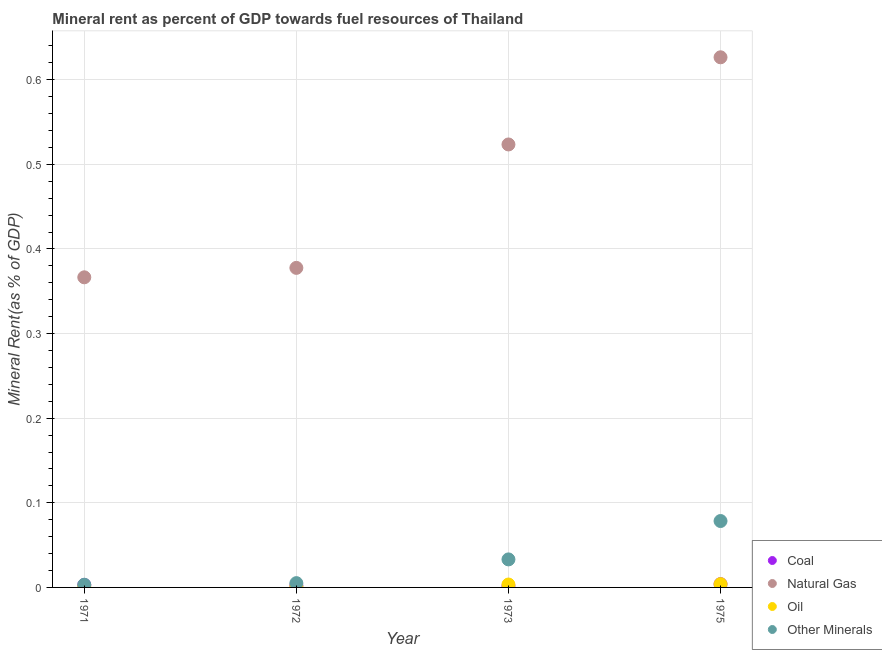What is the  rent of other minerals in 1971?
Your answer should be very brief. 0. Across all years, what is the maximum natural gas rent?
Keep it short and to the point. 0.63. Across all years, what is the minimum coal rent?
Offer a terse response. 0. In which year was the coal rent maximum?
Keep it short and to the point. 1975. What is the total natural gas rent in the graph?
Give a very brief answer. 1.89. What is the difference between the natural gas rent in 1972 and that in 1975?
Ensure brevity in your answer.  -0.25. What is the difference between the natural gas rent in 1972 and the coal rent in 1973?
Your answer should be compact. 0.38. What is the average coal rent per year?
Provide a succinct answer. 0. In the year 1975, what is the difference between the natural gas rent and oil rent?
Provide a succinct answer. 0.62. What is the ratio of the  rent of other minerals in 1971 to that in 1973?
Make the answer very short. 0.1. What is the difference between the highest and the second highest oil rent?
Provide a succinct answer. 0. What is the difference between the highest and the lowest  rent of other minerals?
Give a very brief answer. 0.08. In how many years, is the oil rent greater than the average oil rent taken over all years?
Offer a terse response. 2. Is the sum of the natural gas rent in 1973 and 1975 greater than the maximum  rent of other minerals across all years?
Offer a terse response. Yes. Is it the case that in every year, the sum of the coal rent and natural gas rent is greater than the oil rent?
Give a very brief answer. Yes. Does the  rent of other minerals monotonically increase over the years?
Offer a very short reply. Yes. Does the graph contain any zero values?
Give a very brief answer. No. Does the graph contain grids?
Offer a very short reply. Yes. What is the title of the graph?
Give a very brief answer. Mineral rent as percent of GDP towards fuel resources of Thailand. Does "Public sector management" appear as one of the legend labels in the graph?
Offer a very short reply. No. What is the label or title of the X-axis?
Offer a very short reply. Year. What is the label or title of the Y-axis?
Your answer should be compact. Mineral Rent(as % of GDP). What is the Mineral Rent(as % of GDP) in Coal in 1971?
Your response must be concise. 0. What is the Mineral Rent(as % of GDP) in Natural Gas in 1971?
Your answer should be very brief. 0.37. What is the Mineral Rent(as % of GDP) of Oil in 1971?
Your response must be concise. 0. What is the Mineral Rent(as % of GDP) in Other Minerals in 1971?
Make the answer very short. 0. What is the Mineral Rent(as % of GDP) in Coal in 1972?
Make the answer very short. 0. What is the Mineral Rent(as % of GDP) in Natural Gas in 1972?
Give a very brief answer. 0.38. What is the Mineral Rent(as % of GDP) in Oil in 1972?
Provide a succinct answer. 0. What is the Mineral Rent(as % of GDP) of Other Minerals in 1972?
Provide a succinct answer. 0.01. What is the Mineral Rent(as % of GDP) in Coal in 1973?
Your answer should be very brief. 0. What is the Mineral Rent(as % of GDP) of Natural Gas in 1973?
Provide a short and direct response. 0.52. What is the Mineral Rent(as % of GDP) in Oil in 1973?
Ensure brevity in your answer.  0. What is the Mineral Rent(as % of GDP) in Other Minerals in 1973?
Keep it short and to the point. 0.03. What is the Mineral Rent(as % of GDP) of Coal in 1975?
Offer a terse response. 0. What is the Mineral Rent(as % of GDP) in Natural Gas in 1975?
Your response must be concise. 0.63. What is the Mineral Rent(as % of GDP) in Oil in 1975?
Make the answer very short. 0. What is the Mineral Rent(as % of GDP) of Other Minerals in 1975?
Provide a succinct answer. 0.08. Across all years, what is the maximum Mineral Rent(as % of GDP) of Coal?
Offer a very short reply. 0. Across all years, what is the maximum Mineral Rent(as % of GDP) in Natural Gas?
Ensure brevity in your answer.  0.63. Across all years, what is the maximum Mineral Rent(as % of GDP) in Oil?
Your answer should be compact. 0. Across all years, what is the maximum Mineral Rent(as % of GDP) in Other Minerals?
Your answer should be very brief. 0.08. Across all years, what is the minimum Mineral Rent(as % of GDP) of Coal?
Ensure brevity in your answer.  0. Across all years, what is the minimum Mineral Rent(as % of GDP) in Natural Gas?
Your response must be concise. 0.37. Across all years, what is the minimum Mineral Rent(as % of GDP) in Oil?
Your answer should be compact. 0. Across all years, what is the minimum Mineral Rent(as % of GDP) in Other Minerals?
Ensure brevity in your answer.  0. What is the total Mineral Rent(as % of GDP) in Coal in the graph?
Make the answer very short. 0.01. What is the total Mineral Rent(as % of GDP) of Natural Gas in the graph?
Give a very brief answer. 1.89. What is the total Mineral Rent(as % of GDP) of Oil in the graph?
Ensure brevity in your answer.  0.01. What is the total Mineral Rent(as % of GDP) in Other Minerals in the graph?
Make the answer very short. 0.12. What is the difference between the Mineral Rent(as % of GDP) of Coal in 1971 and that in 1972?
Provide a succinct answer. 0. What is the difference between the Mineral Rent(as % of GDP) of Natural Gas in 1971 and that in 1972?
Give a very brief answer. -0.01. What is the difference between the Mineral Rent(as % of GDP) in Oil in 1971 and that in 1972?
Provide a succinct answer. -0. What is the difference between the Mineral Rent(as % of GDP) of Other Minerals in 1971 and that in 1972?
Your response must be concise. -0. What is the difference between the Mineral Rent(as % of GDP) in Coal in 1971 and that in 1973?
Give a very brief answer. 0. What is the difference between the Mineral Rent(as % of GDP) of Natural Gas in 1971 and that in 1973?
Ensure brevity in your answer.  -0.16. What is the difference between the Mineral Rent(as % of GDP) in Oil in 1971 and that in 1973?
Your answer should be compact. -0. What is the difference between the Mineral Rent(as % of GDP) of Other Minerals in 1971 and that in 1973?
Offer a very short reply. -0.03. What is the difference between the Mineral Rent(as % of GDP) of Coal in 1971 and that in 1975?
Provide a short and direct response. -0. What is the difference between the Mineral Rent(as % of GDP) of Natural Gas in 1971 and that in 1975?
Make the answer very short. -0.26. What is the difference between the Mineral Rent(as % of GDP) of Oil in 1971 and that in 1975?
Offer a terse response. -0. What is the difference between the Mineral Rent(as % of GDP) in Other Minerals in 1971 and that in 1975?
Offer a very short reply. -0.08. What is the difference between the Mineral Rent(as % of GDP) in Coal in 1972 and that in 1973?
Offer a terse response. 0. What is the difference between the Mineral Rent(as % of GDP) of Natural Gas in 1972 and that in 1973?
Offer a very short reply. -0.15. What is the difference between the Mineral Rent(as % of GDP) of Oil in 1972 and that in 1973?
Your answer should be very brief. -0. What is the difference between the Mineral Rent(as % of GDP) of Other Minerals in 1972 and that in 1973?
Give a very brief answer. -0.03. What is the difference between the Mineral Rent(as % of GDP) in Coal in 1972 and that in 1975?
Make the answer very short. -0. What is the difference between the Mineral Rent(as % of GDP) of Natural Gas in 1972 and that in 1975?
Ensure brevity in your answer.  -0.25. What is the difference between the Mineral Rent(as % of GDP) in Oil in 1972 and that in 1975?
Your answer should be compact. -0. What is the difference between the Mineral Rent(as % of GDP) in Other Minerals in 1972 and that in 1975?
Provide a short and direct response. -0.07. What is the difference between the Mineral Rent(as % of GDP) in Coal in 1973 and that in 1975?
Keep it short and to the point. -0. What is the difference between the Mineral Rent(as % of GDP) of Natural Gas in 1973 and that in 1975?
Provide a succinct answer. -0.1. What is the difference between the Mineral Rent(as % of GDP) of Oil in 1973 and that in 1975?
Give a very brief answer. -0. What is the difference between the Mineral Rent(as % of GDP) of Other Minerals in 1973 and that in 1975?
Make the answer very short. -0.05. What is the difference between the Mineral Rent(as % of GDP) in Coal in 1971 and the Mineral Rent(as % of GDP) in Natural Gas in 1972?
Give a very brief answer. -0.37. What is the difference between the Mineral Rent(as % of GDP) of Coal in 1971 and the Mineral Rent(as % of GDP) of Oil in 1972?
Your answer should be very brief. 0. What is the difference between the Mineral Rent(as % of GDP) in Coal in 1971 and the Mineral Rent(as % of GDP) in Other Minerals in 1972?
Make the answer very short. -0. What is the difference between the Mineral Rent(as % of GDP) of Natural Gas in 1971 and the Mineral Rent(as % of GDP) of Oil in 1972?
Ensure brevity in your answer.  0.37. What is the difference between the Mineral Rent(as % of GDP) in Natural Gas in 1971 and the Mineral Rent(as % of GDP) in Other Minerals in 1972?
Give a very brief answer. 0.36. What is the difference between the Mineral Rent(as % of GDP) in Oil in 1971 and the Mineral Rent(as % of GDP) in Other Minerals in 1972?
Offer a terse response. -0. What is the difference between the Mineral Rent(as % of GDP) in Coal in 1971 and the Mineral Rent(as % of GDP) in Natural Gas in 1973?
Keep it short and to the point. -0.52. What is the difference between the Mineral Rent(as % of GDP) in Coal in 1971 and the Mineral Rent(as % of GDP) in Oil in 1973?
Give a very brief answer. -0. What is the difference between the Mineral Rent(as % of GDP) of Coal in 1971 and the Mineral Rent(as % of GDP) of Other Minerals in 1973?
Your answer should be compact. -0.03. What is the difference between the Mineral Rent(as % of GDP) of Natural Gas in 1971 and the Mineral Rent(as % of GDP) of Oil in 1973?
Your answer should be compact. 0.36. What is the difference between the Mineral Rent(as % of GDP) in Natural Gas in 1971 and the Mineral Rent(as % of GDP) in Other Minerals in 1973?
Make the answer very short. 0.33. What is the difference between the Mineral Rent(as % of GDP) of Oil in 1971 and the Mineral Rent(as % of GDP) of Other Minerals in 1973?
Your answer should be compact. -0.03. What is the difference between the Mineral Rent(as % of GDP) in Coal in 1971 and the Mineral Rent(as % of GDP) in Natural Gas in 1975?
Keep it short and to the point. -0.62. What is the difference between the Mineral Rent(as % of GDP) in Coal in 1971 and the Mineral Rent(as % of GDP) in Oil in 1975?
Give a very brief answer. -0. What is the difference between the Mineral Rent(as % of GDP) in Coal in 1971 and the Mineral Rent(as % of GDP) in Other Minerals in 1975?
Offer a terse response. -0.08. What is the difference between the Mineral Rent(as % of GDP) of Natural Gas in 1971 and the Mineral Rent(as % of GDP) of Oil in 1975?
Ensure brevity in your answer.  0.36. What is the difference between the Mineral Rent(as % of GDP) in Natural Gas in 1971 and the Mineral Rent(as % of GDP) in Other Minerals in 1975?
Offer a very short reply. 0.29. What is the difference between the Mineral Rent(as % of GDP) in Oil in 1971 and the Mineral Rent(as % of GDP) in Other Minerals in 1975?
Ensure brevity in your answer.  -0.08. What is the difference between the Mineral Rent(as % of GDP) in Coal in 1972 and the Mineral Rent(as % of GDP) in Natural Gas in 1973?
Your answer should be compact. -0.52. What is the difference between the Mineral Rent(as % of GDP) of Coal in 1972 and the Mineral Rent(as % of GDP) of Oil in 1973?
Make the answer very short. -0. What is the difference between the Mineral Rent(as % of GDP) of Coal in 1972 and the Mineral Rent(as % of GDP) of Other Minerals in 1973?
Provide a succinct answer. -0.03. What is the difference between the Mineral Rent(as % of GDP) of Natural Gas in 1972 and the Mineral Rent(as % of GDP) of Oil in 1973?
Make the answer very short. 0.37. What is the difference between the Mineral Rent(as % of GDP) of Natural Gas in 1972 and the Mineral Rent(as % of GDP) of Other Minerals in 1973?
Your answer should be compact. 0.34. What is the difference between the Mineral Rent(as % of GDP) in Oil in 1972 and the Mineral Rent(as % of GDP) in Other Minerals in 1973?
Keep it short and to the point. -0.03. What is the difference between the Mineral Rent(as % of GDP) in Coal in 1972 and the Mineral Rent(as % of GDP) in Natural Gas in 1975?
Offer a very short reply. -0.62. What is the difference between the Mineral Rent(as % of GDP) in Coal in 1972 and the Mineral Rent(as % of GDP) in Oil in 1975?
Your answer should be compact. -0. What is the difference between the Mineral Rent(as % of GDP) of Coal in 1972 and the Mineral Rent(as % of GDP) of Other Minerals in 1975?
Your answer should be compact. -0.08. What is the difference between the Mineral Rent(as % of GDP) of Natural Gas in 1972 and the Mineral Rent(as % of GDP) of Oil in 1975?
Ensure brevity in your answer.  0.37. What is the difference between the Mineral Rent(as % of GDP) of Natural Gas in 1972 and the Mineral Rent(as % of GDP) of Other Minerals in 1975?
Keep it short and to the point. 0.3. What is the difference between the Mineral Rent(as % of GDP) in Oil in 1972 and the Mineral Rent(as % of GDP) in Other Minerals in 1975?
Make the answer very short. -0.08. What is the difference between the Mineral Rent(as % of GDP) of Coal in 1973 and the Mineral Rent(as % of GDP) of Natural Gas in 1975?
Make the answer very short. -0.62. What is the difference between the Mineral Rent(as % of GDP) of Coal in 1973 and the Mineral Rent(as % of GDP) of Oil in 1975?
Provide a short and direct response. -0. What is the difference between the Mineral Rent(as % of GDP) of Coal in 1973 and the Mineral Rent(as % of GDP) of Other Minerals in 1975?
Offer a very short reply. -0.08. What is the difference between the Mineral Rent(as % of GDP) of Natural Gas in 1973 and the Mineral Rent(as % of GDP) of Oil in 1975?
Provide a short and direct response. 0.52. What is the difference between the Mineral Rent(as % of GDP) in Natural Gas in 1973 and the Mineral Rent(as % of GDP) in Other Minerals in 1975?
Offer a very short reply. 0.45. What is the difference between the Mineral Rent(as % of GDP) in Oil in 1973 and the Mineral Rent(as % of GDP) in Other Minerals in 1975?
Make the answer very short. -0.07. What is the average Mineral Rent(as % of GDP) of Coal per year?
Offer a very short reply. 0. What is the average Mineral Rent(as % of GDP) of Natural Gas per year?
Make the answer very short. 0.47. What is the average Mineral Rent(as % of GDP) in Oil per year?
Keep it short and to the point. 0. In the year 1971, what is the difference between the Mineral Rent(as % of GDP) of Coal and Mineral Rent(as % of GDP) of Natural Gas?
Your response must be concise. -0.36. In the year 1971, what is the difference between the Mineral Rent(as % of GDP) of Coal and Mineral Rent(as % of GDP) of Oil?
Ensure brevity in your answer.  0. In the year 1971, what is the difference between the Mineral Rent(as % of GDP) in Coal and Mineral Rent(as % of GDP) in Other Minerals?
Your answer should be very brief. -0. In the year 1971, what is the difference between the Mineral Rent(as % of GDP) of Natural Gas and Mineral Rent(as % of GDP) of Oil?
Ensure brevity in your answer.  0.37. In the year 1971, what is the difference between the Mineral Rent(as % of GDP) of Natural Gas and Mineral Rent(as % of GDP) of Other Minerals?
Offer a very short reply. 0.36. In the year 1971, what is the difference between the Mineral Rent(as % of GDP) in Oil and Mineral Rent(as % of GDP) in Other Minerals?
Provide a short and direct response. -0. In the year 1972, what is the difference between the Mineral Rent(as % of GDP) in Coal and Mineral Rent(as % of GDP) in Natural Gas?
Your response must be concise. -0.38. In the year 1972, what is the difference between the Mineral Rent(as % of GDP) of Coal and Mineral Rent(as % of GDP) of Oil?
Give a very brief answer. 0. In the year 1972, what is the difference between the Mineral Rent(as % of GDP) of Coal and Mineral Rent(as % of GDP) of Other Minerals?
Provide a succinct answer. -0. In the year 1972, what is the difference between the Mineral Rent(as % of GDP) in Natural Gas and Mineral Rent(as % of GDP) in Oil?
Keep it short and to the point. 0.38. In the year 1972, what is the difference between the Mineral Rent(as % of GDP) of Natural Gas and Mineral Rent(as % of GDP) of Other Minerals?
Make the answer very short. 0.37. In the year 1972, what is the difference between the Mineral Rent(as % of GDP) in Oil and Mineral Rent(as % of GDP) in Other Minerals?
Offer a very short reply. -0. In the year 1973, what is the difference between the Mineral Rent(as % of GDP) in Coal and Mineral Rent(as % of GDP) in Natural Gas?
Your answer should be very brief. -0.52. In the year 1973, what is the difference between the Mineral Rent(as % of GDP) of Coal and Mineral Rent(as % of GDP) of Oil?
Keep it short and to the point. -0. In the year 1973, what is the difference between the Mineral Rent(as % of GDP) in Coal and Mineral Rent(as % of GDP) in Other Minerals?
Keep it short and to the point. -0.03. In the year 1973, what is the difference between the Mineral Rent(as % of GDP) of Natural Gas and Mineral Rent(as % of GDP) of Oil?
Make the answer very short. 0.52. In the year 1973, what is the difference between the Mineral Rent(as % of GDP) in Natural Gas and Mineral Rent(as % of GDP) in Other Minerals?
Make the answer very short. 0.49. In the year 1973, what is the difference between the Mineral Rent(as % of GDP) of Oil and Mineral Rent(as % of GDP) of Other Minerals?
Provide a short and direct response. -0.03. In the year 1975, what is the difference between the Mineral Rent(as % of GDP) of Coal and Mineral Rent(as % of GDP) of Natural Gas?
Ensure brevity in your answer.  -0.62. In the year 1975, what is the difference between the Mineral Rent(as % of GDP) of Coal and Mineral Rent(as % of GDP) of Other Minerals?
Offer a terse response. -0.07. In the year 1975, what is the difference between the Mineral Rent(as % of GDP) of Natural Gas and Mineral Rent(as % of GDP) of Oil?
Offer a very short reply. 0.62. In the year 1975, what is the difference between the Mineral Rent(as % of GDP) in Natural Gas and Mineral Rent(as % of GDP) in Other Minerals?
Offer a very short reply. 0.55. In the year 1975, what is the difference between the Mineral Rent(as % of GDP) in Oil and Mineral Rent(as % of GDP) in Other Minerals?
Give a very brief answer. -0.07. What is the ratio of the Mineral Rent(as % of GDP) in Coal in 1971 to that in 1972?
Ensure brevity in your answer.  1.37. What is the ratio of the Mineral Rent(as % of GDP) of Natural Gas in 1971 to that in 1972?
Provide a succinct answer. 0.97. What is the ratio of the Mineral Rent(as % of GDP) in Oil in 1971 to that in 1972?
Your response must be concise. 0.84. What is the ratio of the Mineral Rent(as % of GDP) in Other Minerals in 1971 to that in 1972?
Offer a very short reply. 0.63. What is the ratio of the Mineral Rent(as % of GDP) of Coal in 1971 to that in 1973?
Keep it short and to the point. 1.9. What is the ratio of the Mineral Rent(as % of GDP) of Natural Gas in 1971 to that in 1973?
Provide a short and direct response. 0.7. What is the ratio of the Mineral Rent(as % of GDP) of Oil in 1971 to that in 1973?
Your answer should be very brief. 0.26. What is the ratio of the Mineral Rent(as % of GDP) of Other Minerals in 1971 to that in 1973?
Make the answer very short. 0.1. What is the ratio of the Mineral Rent(as % of GDP) in Coal in 1971 to that in 1975?
Provide a succinct answer. 0.75. What is the ratio of the Mineral Rent(as % of GDP) of Natural Gas in 1971 to that in 1975?
Your response must be concise. 0.58. What is the ratio of the Mineral Rent(as % of GDP) of Oil in 1971 to that in 1975?
Make the answer very short. 0.23. What is the ratio of the Mineral Rent(as % of GDP) in Other Minerals in 1971 to that in 1975?
Your response must be concise. 0.04. What is the ratio of the Mineral Rent(as % of GDP) in Coal in 1972 to that in 1973?
Provide a short and direct response. 1.39. What is the ratio of the Mineral Rent(as % of GDP) of Natural Gas in 1972 to that in 1973?
Your answer should be very brief. 0.72. What is the ratio of the Mineral Rent(as % of GDP) of Oil in 1972 to that in 1973?
Your answer should be compact. 0.31. What is the ratio of the Mineral Rent(as % of GDP) of Other Minerals in 1972 to that in 1973?
Make the answer very short. 0.15. What is the ratio of the Mineral Rent(as % of GDP) in Coal in 1972 to that in 1975?
Your answer should be compact. 0.55. What is the ratio of the Mineral Rent(as % of GDP) in Natural Gas in 1972 to that in 1975?
Provide a succinct answer. 0.6. What is the ratio of the Mineral Rent(as % of GDP) of Oil in 1972 to that in 1975?
Your response must be concise. 0.27. What is the ratio of the Mineral Rent(as % of GDP) in Other Minerals in 1972 to that in 1975?
Offer a terse response. 0.06. What is the ratio of the Mineral Rent(as % of GDP) in Coal in 1973 to that in 1975?
Provide a short and direct response. 0.4. What is the ratio of the Mineral Rent(as % of GDP) of Natural Gas in 1973 to that in 1975?
Your answer should be very brief. 0.84. What is the ratio of the Mineral Rent(as % of GDP) in Oil in 1973 to that in 1975?
Your answer should be very brief. 0.88. What is the ratio of the Mineral Rent(as % of GDP) of Other Minerals in 1973 to that in 1975?
Your answer should be compact. 0.42. What is the difference between the highest and the second highest Mineral Rent(as % of GDP) in Coal?
Your answer should be compact. 0. What is the difference between the highest and the second highest Mineral Rent(as % of GDP) of Natural Gas?
Make the answer very short. 0.1. What is the difference between the highest and the second highest Mineral Rent(as % of GDP) in Oil?
Offer a very short reply. 0. What is the difference between the highest and the second highest Mineral Rent(as % of GDP) in Other Minerals?
Provide a short and direct response. 0.05. What is the difference between the highest and the lowest Mineral Rent(as % of GDP) in Coal?
Your answer should be compact. 0. What is the difference between the highest and the lowest Mineral Rent(as % of GDP) of Natural Gas?
Keep it short and to the point. 0.26. What is the difference between the highest and the lowest Mineral Rent(as % of GDP) in Oil?
Your answer should be compact. 0. What is the difference between the highest and the lowest Mineral Rent(as % of GDP) of Other Minerals?
Ensure brevity in your answer.  0.08. 